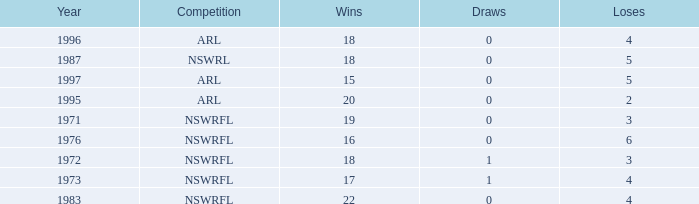What average Year has Losses 4, and Wins less than 18, and Draws greater than 1? None. 